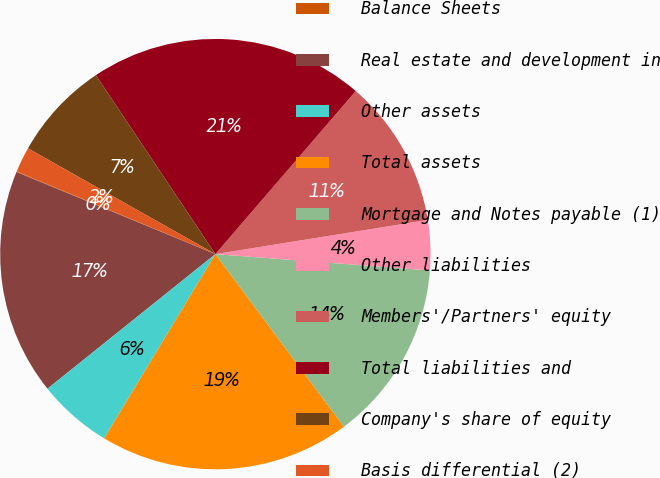Convert chart. <chart><loc_0><loc_0><loc_500><loc_500><pie_chart><fcel>Balance Sheets<fcel>Real estate and development in<fcel>Other assets<fcel>Total assets<fcel>Mortgage and Notes payable (1)<fcel>Other liabilities<fcel>Members'/Partners' equity<fcel>Total liabilities and<fcel>Company's share of equity<fcel>Basis differential (2)<nl><fcel>0.05%<fcel>16.99%<fcel>5.6%<fcel>18.84%<fcel>13.6%<fcel>3.75%<fcel>11.15%<fcel>20.69%<fcel>7.45%<fcel>1.9%<nl></chart> 